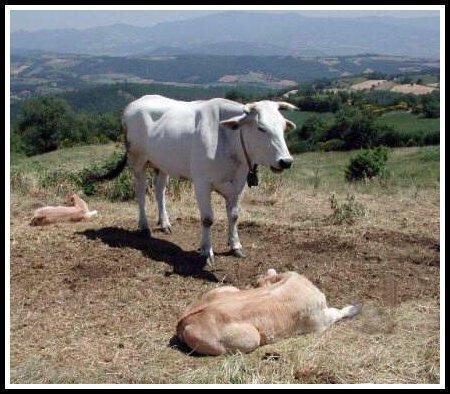How many cows can you see?
Give a very brief answer. 2. 